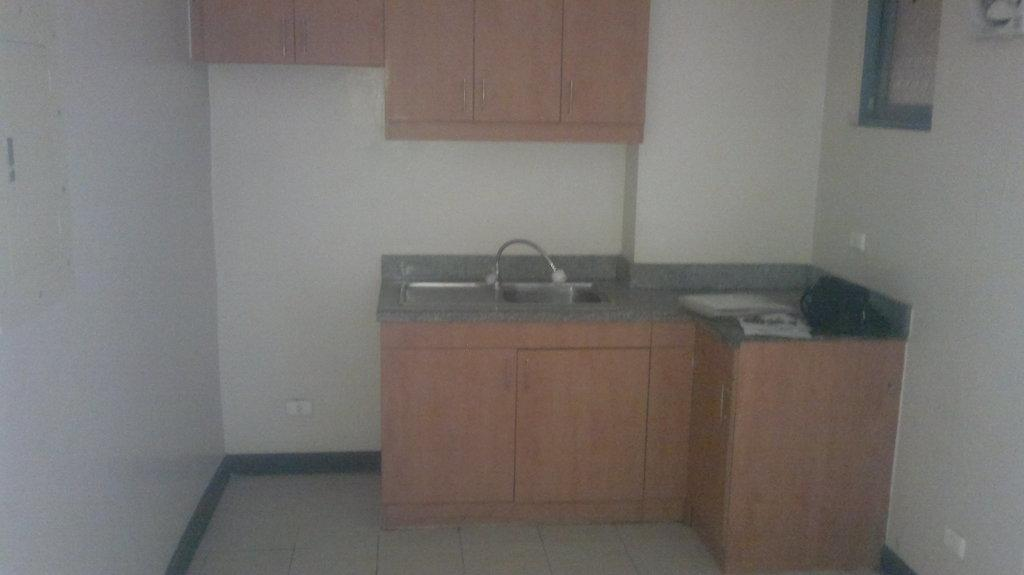What is the main fixture in the image? There is a sink in the image. What is attached to the sink? There is a tap attached to the sink. What can be seen in the background of the image? There are cupboards in the background of the image. What is the color of the cupboards? The cupboards are in brown color. What is the color of the wall in the image? The wall is in cream color. What type of circle is visible on the skirt of the person in the image? There is no person or skirt present in the image; it features a sink, a tap, cupboards, and a wall. Is there any coal being used for heating in the image? There is no coal or any heating element present in the image. 